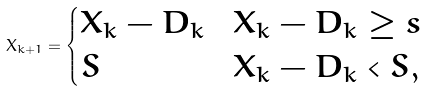Convert formula to latex. <formula><loc_0><loc_0><loc_500><loc_500>X _ { k + 1 } = \begin{cases} X _ { k } - D _ { k } & X _ { k } - D _ { k } \geq s \\ S & X _ { k } - D _ { k } < S , \end{cases}</formula> 